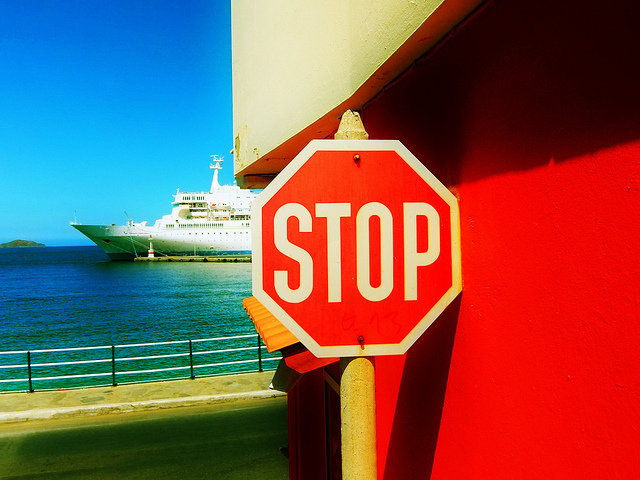What color is the stop sign and what does it indicate? The stop sign is red with white lettering, which universally indicates to drivers that they must come to a complete stop and yield to any other traffic or pedestrians before proceeding. 